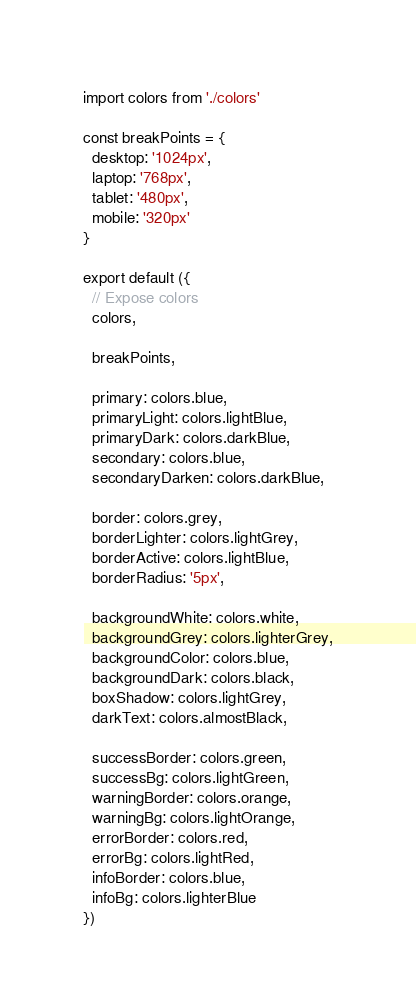Convert code to text. <code><loc_0><loc_0><loc_500><loc_500><_JavaScript_>import colors from './colors'

const breakPoints = {
  desktop: '1024px',
  laptop: '768px',
  tablet: '480px',
  mobile: '320px'
}

export default ({
  // Expose colors
  colors,

  breakPoints,

  primary: colors.blue,
  primaryLight: colors.lightBlue,
  primaryDark: colors.darkBlue,
  secondary: colors.blue,
  secondaryDarken: colors.darkBlue,

  border: colors.grey,
  borderLighter: colors.lightGrey,
  borderActive: colors.lightBlue,
  borderRadius: '5px',

  backgroundWhite: colors.white,
  backgroundGrey: colors.lighterGrey,
  backgroundColor: colors.blue,
  backgroundDark: colors.black,
  boxShadow: colors.lightGrey,
  darkText: colors.almostBlack,

  successBorder: colors.green,
  successBg: colors.lightGreen,
  warningBorder: colors.orange,
  warningBg: colors.lightOrange,
  errorBorder: colors.red,
  errorBg: colors.lightRed,
  infoBorder: colors.blue,
  infoBg: colors.lighterBlue
})
</code> 